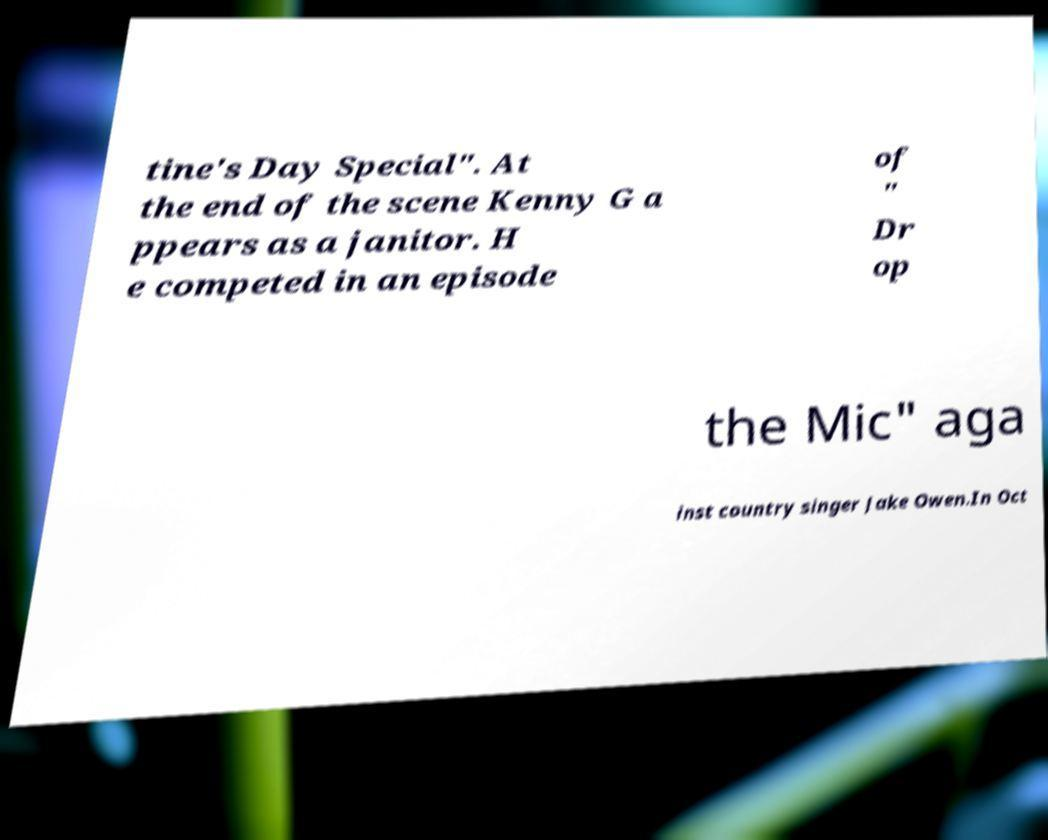Can you accurately transcribe the text from the provided image for me? tine's Day Special". At the end of the scene Kenny G a ppears as a janitor. H e competed in an episode of " Dr op the Mic" aga inst country singer Jake Owen.In Oct 